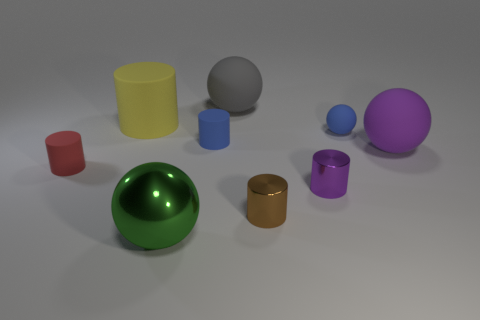What is the size of the matte thing that is the same color as the small matte sphere?
Keep it short and to the point. Small. Is the number of large purple things less than the number of large purple matte cylinders?
Provide a short and direct response. No. There is a sphere that is the same size as the brown object; what material is it?
Give a very brief answer. Rubber. Is the number of green metallic cylinders greater than the number of big gray things?
Your answer should be compact. No. How many other objects are there of the same color as the small sphere?
Your response must be concise. 1. What number of large things are both behind the blue matte cylinder and right of the green metallic ball?
Make the answer very short. 1. Are there more spheres left of the tiny blue matte sphere than large yellow cylinders behind the small purple cylinder?
Offer a very short reply. Yes. There is a small cylinder that is behind the red rubber object; what is it made of?
Your response must be concise. Rubber. There is a purple matte thing; is it the same shape as the big matte object that is behind the big rubber cylinder?
Offer a very short reply. Yes. There is a blue thing that is to the right of the big sphere that is behind the large rubber cylinder; how many shiny cylinders are on the left side of it?
Offer a very short reply. 2. 